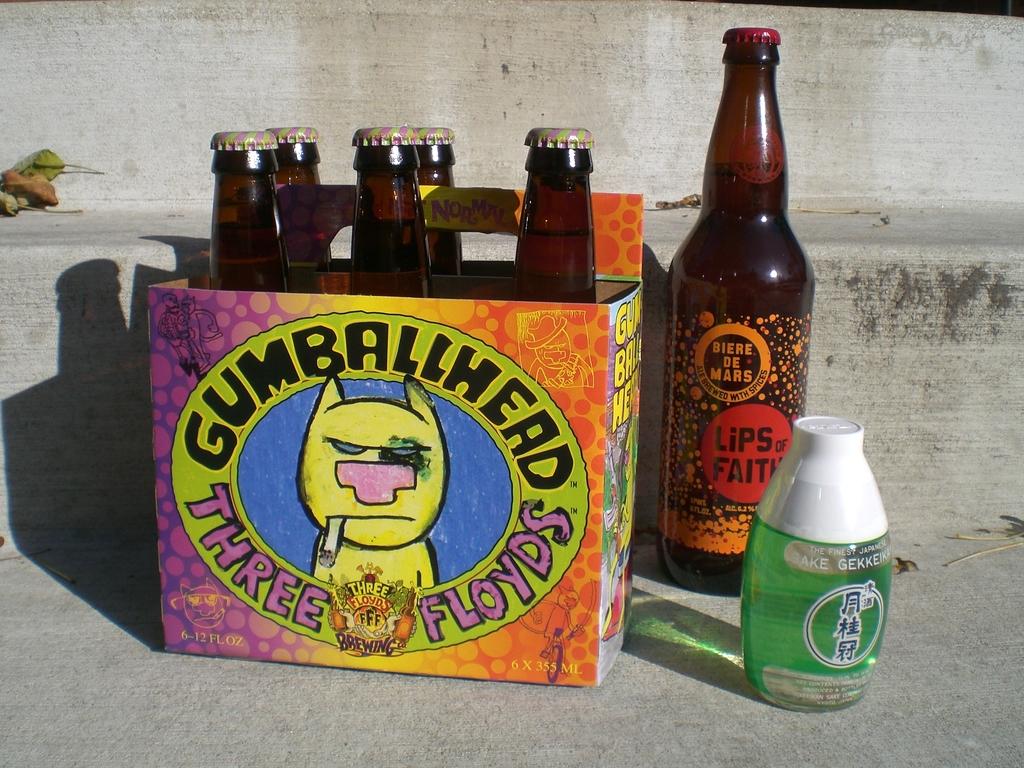What type of bumballhead is the beer?
Provide a short and direct response. Three floyds. What is the name of the beer?
Give a very brief answer. Gumballhead. 